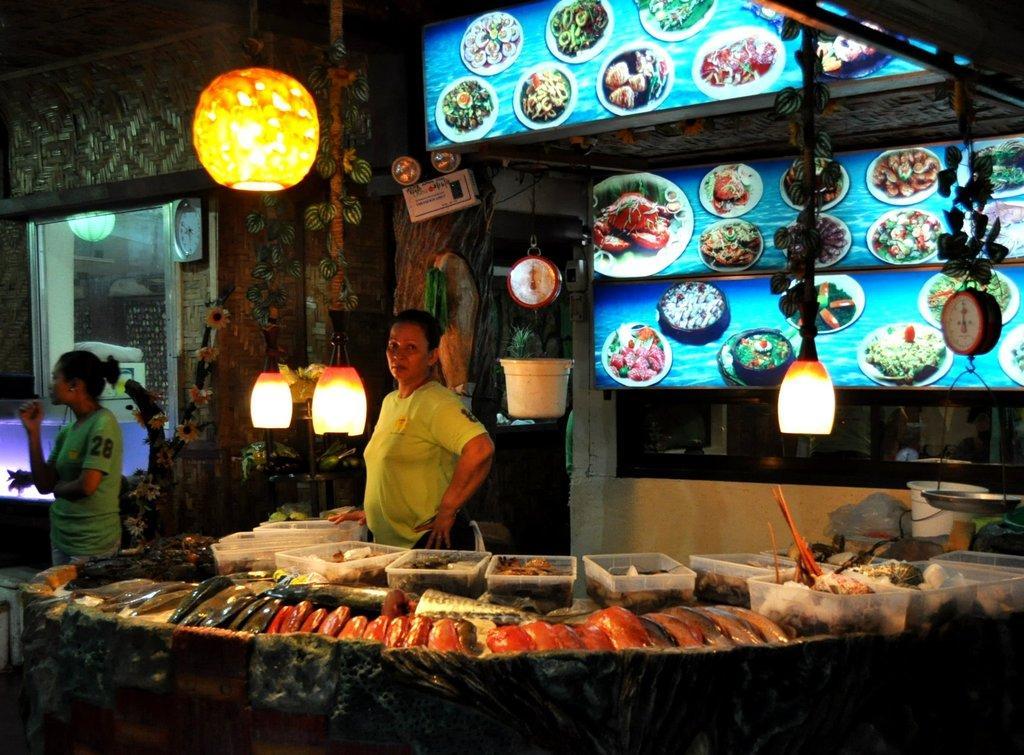How would you summarize this image in a sentence or two? In the image there is a woman in green t-shirt selling fish and meat, it seems to be clicked at night time, behind and above her there are lights followed by label boards in the background, on the left side there is another woman standing, behind her it seems to be building with a clock on the wall. 